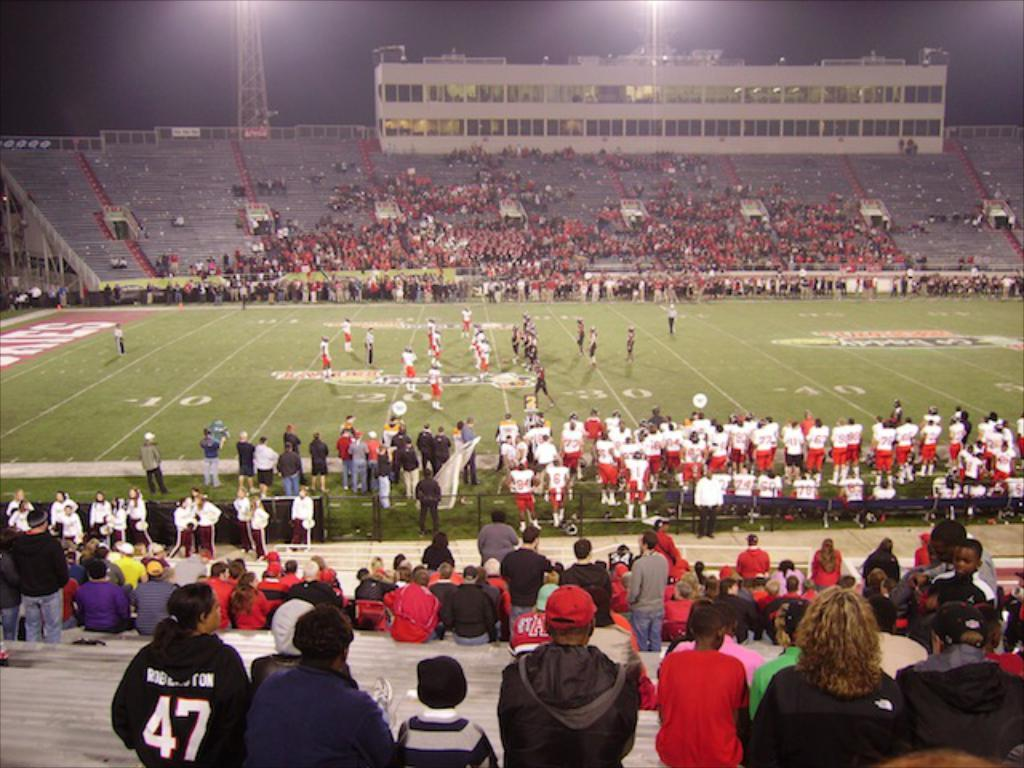What are the people in the image doing? The people in the image are standing and seated in various locations. Where are the seated people located in the image? Some people are seated on the left side and some on the right side of the image. What type of location is depicted in the image? The image shows a stadium. What structure is visible in the image? There is a building visible in the image. What can be seen supporting the lights in the image? There are lights on poles in the image. What type of star can be seen in the image? There is no star visible in the image. What kind of wheel is being used by the people in the image? There is no wheel present in the image; the people are standing or seated in a stadium. 